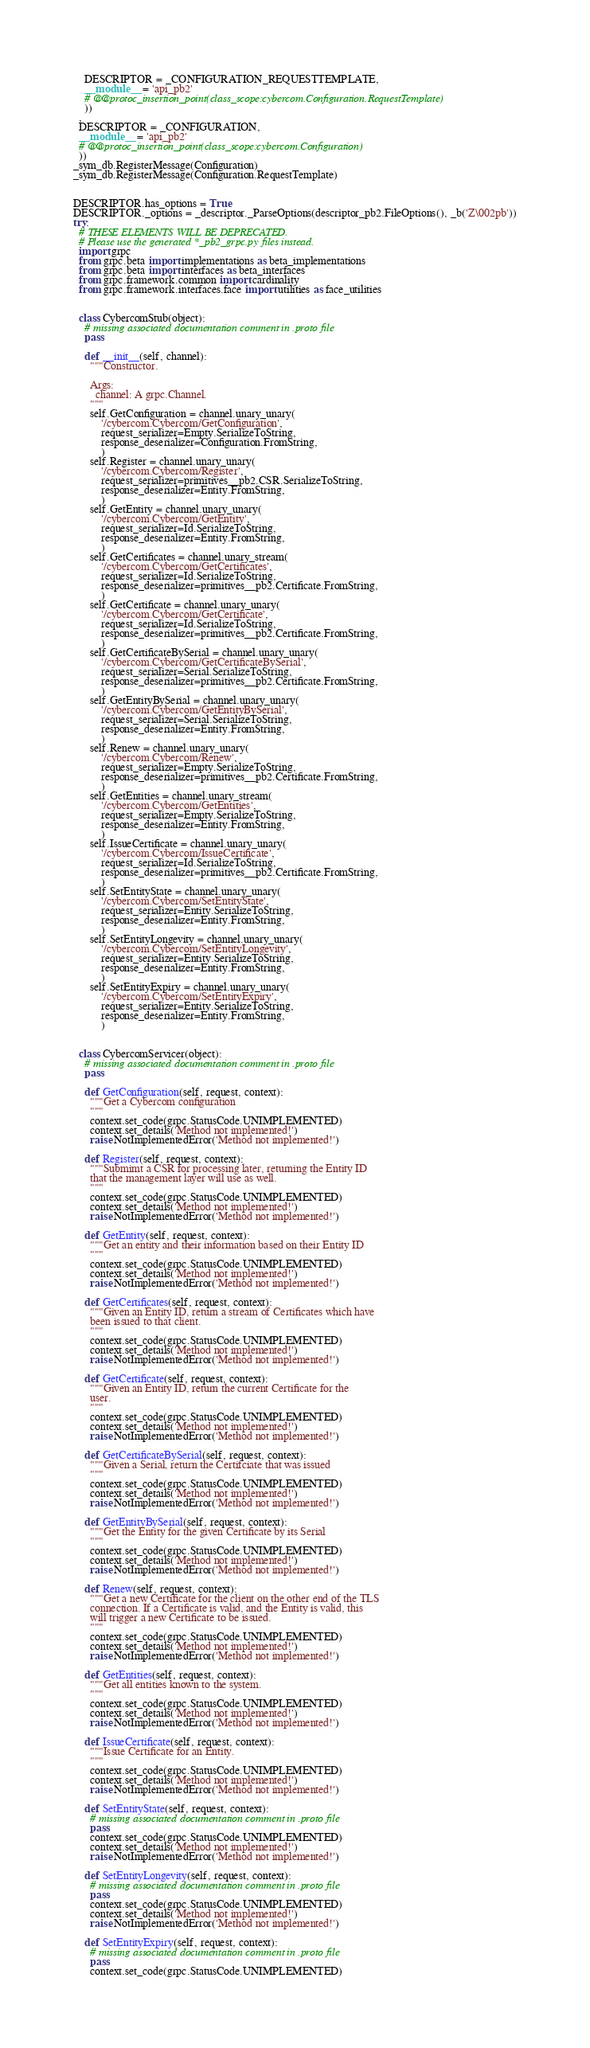<code> <loc_0><loc_0><loc_500><loc_500><_Python_>    DESCRIPTOR = _CONFIGURATION_REQUESTTEMPLATE,
    __module__ = 'api_pb2'
    # @@protoc_insertion_point(class_scope:cybercom.Configuration.RequestTemplate)
    ))
  ,
  DESCRIPTOR = _CONFIGURATION,
  __module__ = 'api_pb2'
  # @@protoc_insertion_point(class_scope:cybercom.Configuration)
  ))
_sym_db.RegisterMessage(Configuration)
_sym_db.RegisterMessage(Configuration.RequestTemplate)


DESCRIPTOR.has_options = True
DESCRIPTOR._options = _descriptor._ParseOptions(descriptor_pb2.FileOptions(), _b('Z\002pb'))
try:
  # THESE ELEMENTS WILL BE DEPRECATED.
  # Please use the generated *_pb2_grpc.py files instead.
  import grpc
  from grpc.beta import implementations as beta_implementations
  from grpc.beta import interfaces as beta_interfaces
  from grpc.framework.common import cardinality
  from grpc.framework.interfaces.face import utilities as face_utilities


  class CybercomStub(object):
    # missing associated documentation comment in .proto file
    pass

    def __init__(self, channel):
      """Constructor.

      Args:
        channel: A grpc.Channel.
      """
      self.GetConfiguration = channel.unary_unary(
          '/cybercom.Cybercom/GetConfiguration',
          request_serializer=Empty.SerializeToString,
          response_deserializer=Configuration.FromString,
          )
      self.Register = channel.unary_unary(
          '/cybercom.Cybercom/Register',
          request_serializer=primitives__pb2.CSR.SerializeToString,
          response_deserializer=Entity.FromString,
          )
      self.GetEntity = channel.unary_unary(
          '/cybercom.Cybercom/GetEntity',
          request_serializer=Id.SerializeToString,
          response_deserializer=Entity.FromString,
          )
      self.GetCertificates = channel.unary_stream(
          '/cybercom.Cybercom/GetCertificates',
          request_serializer=Id.SerializeToString,
          response_deserializer=primitives__pb2.Certificate.FromString,
          )
      self.GetCertificate = channel.unary_unary(
          '/cybercom.Cybercom/GetCertificate',
          request_serializer=Id.SerializeToString,
          response_deserializer=primitives__pb2.Certificate.FromString,
          )
      self.GetCertificateBySerial = channel.unary_unary(
          '/cybercom.Cybercom/GetCertificateBySerial',
          request_serializer=Serial.SerializeToString,
          response_deserializer=primitives__pb2.Certificate.FromString,
          )
      self.GetEntityBySerial = channel.unary_unary(
          '/cybercom.Cybercom/GetEntityBySerial',
          request_serializer=Serial.SerializeToString,
          response_deserializer=Entity.FromString,
          )
      self.Renew = channel.unary_unary(
          '/cybercom.Cybercom/Renew',
          request_serializer=Empty.SerializeToString,
          response_deserializer=primitives__pb2.Certificate.FromString,
          )
      self.GetEntities = channel.unary_stream(
          '/cybercom.Cybercom/GetEntities',
          request_serializer=Empty.SerializeToString,
          response_deserializer=Entity.FromString,
          )
      self.IssueCertificate = channel.unary_unary(
          '/cybercom.Cybercom/IssueCertificate',
          request_serializer=Id.SerializeToString,
          response_deserializer=primitives__pb2.Certificate.FromString,
          )
      self.SetEntityState = channel.unary_unary(
          '/cybercom.Cybercom/SetEntityState',
          request_serializer=Entity.SerializeToString,
          response_deserializer=Entity.FromString,
          )
      self.SetEntityLongevity = channel.unary_unary(
          '/cybercom.Cybercom/SetEntityLongevity',
          request_serializer=Entity.SerializeToString,
          response_deserializer=Entity.FromString,
          )
      self.SetEntityExpiry = channel.unary_unary(
          '/cybercom.Cybercom/SetEntityExpiry',
          request_serializer=Entity.SerializeToString,
          response_deserializer=Entity.FromString,
          )


  class CybercomServicer(object):
    # missing associated documentation comment in .proto file
    pass

    def GetConfiguration(self, request, context):
      """Get a Cybercom configuration
      """
      context.set_code(grpc.StatusCode.UNIMPLEMENTED)
      context.set_details('Method not implemented!')
      raise NotImplementedError('Method not implemented!')

    def Register(self, request, context):
      """Submimt a CSR for processing later, returning the Entity ID
      that the management layer will use as well.
      """
      context.set_code(grpc.StatusCode.UNIMPLEMENTED)
      context.set_details('Method not implemented!')
      raise NotImplementedError('Method not implemented!')

    def GetEntity(self, request, context):
      """Get an entity and their information based on their Entity ID
      """
      context.set_code(grpc.StatusCode.UNIMPLEMENTED)
      context.set_details('Method not implemented!')
      raise NotImplementedError('Method not implemented!')

    def GetCertificates(self, request, context):
      """Given an Entity ID, return a stream of Certificates which have
      been issued to that client.
      """
      context.set_code(grpc.StatusCode.UNIMPLEMENTED)
      context.set_details('Method not implemented!')
      raise NotImplementedError('Method not implemented!')

    def GetCertificate(self, request, context):
      """Given an Entity ID, return the current Certificate for the
      user.
      """
      context.set_code(grpc.StatusCode.UNIMPLEMENTED)
      context.set_details('Method not implemented!')
      raise NotImplementedError('Method not implemented!')

    def GetCertificateBySerial(self, request, context):
      """Given a Serial, return the Certifciate that was issued
      """
      context.set_code(grpc.StatusCode.UNIMPLEMENTED)
      context.set_details('Method not implemented!')
      raise NotImplementedError('Method not implemented!')

    def GetEntityBySerial(self, request, context):
      """Get the Entity for the given Certificate by its Serial
      """
      context.set_code(grpc.StatusCode.UNIMPLEMENTED)
      context.set_details('Method not implemented!')
      raise NotImplementedError('Method not implemented!')

    def Renew(self, request, context):
      """Get a new Certificate for the client on the other end of the TLS
      connection. If a Certificate is valid, and the Entity is valid, this
      will trigger a new Certificate to be issued.
      """
      context.set_code(grpc.StatusCode.UNIMPLEMENTED)
      context.set_details('Method not implemented!')
      raise NotImplementedError('Method not implemented!')

    def GetEntities(self, request, context):
      """Get all entities known to the system.
      """
      context.set_code(grpc.StatusCode.UNIMPLEMENTED)
      context.set_details('Method not implemented!')
      raise NotImplementedError('Method not implemented!')

    def IssueCertificate(self, request, context):
      """Issue Certificate for an Entity.
      """
      context.set_code(grpc.StatusCode.UNIMPLEMENTED)
      context.set_details('Method not implemented!')
      raise NotImplementedError('Method not implemented!')

    def SetEntityState(self, request, context):
      # missing associated documentation comment in .proto file
      pass
      context.set_code(grpc.StatusCode.UNIMPLEMENTED)
      context.set_details('Method not implemented!')
      raise NotImplementedError('Method not implemented!')

    def SetEntityLongevity(self, request, context):
      # missing associated documentation comment in .proto file
      pass
      context.set_code(grpc.StatusCode.UNIMPLEMENTED)
      context.set_details('Method not implemented!')
      raise NotImplementedError('Method not implemented!')

    def SetEntityExpiry(self, request, context):
      # missing associated documentation comment in .proto file
      pass
      context.set_code(grpc.StatusCode.UNIMPLEMENTED)</code> 